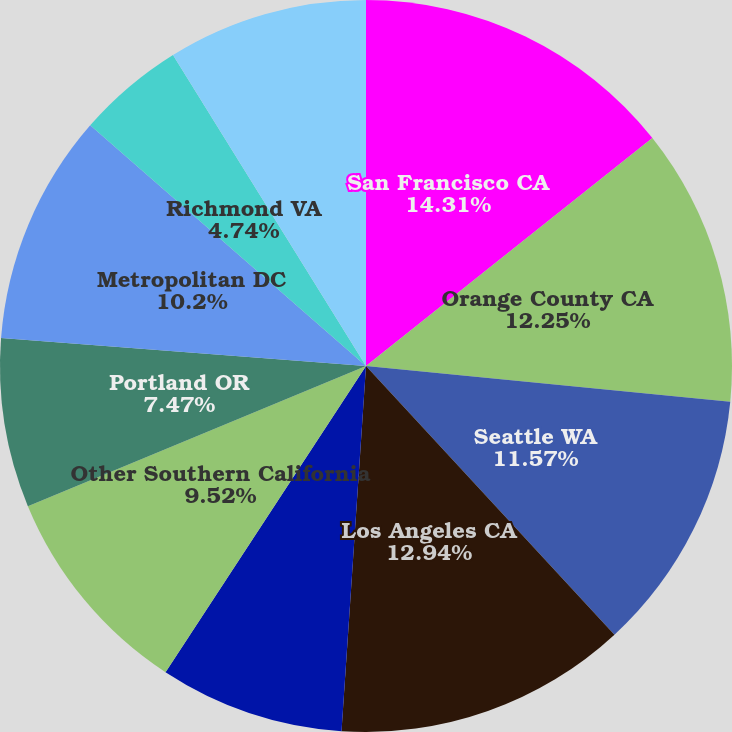Convert chart. <chart><loc_0><loc_0><loc_500><loc_500><pie_chart><fcel>San Francisco CA<fcel>Orange County CA<fcel>Seattle WA<fcel>Los Angeles CA<fcel>Monterey Peninsula CA<fcel>Other Southern California<fcel>Portland OR<fcel>Metropolitan DC<fcel>Richmond VA<fcel>Baltimore MD<nl><fcel>14.3%<fcel>12.25%<fcel>11.57%<fcel>12.94%<fcel>8.16%<fcel>9.52%<fcel>7.47%<fcel>10.2%<fcel>4.74%<fcel>8.84%<nl></chart> 